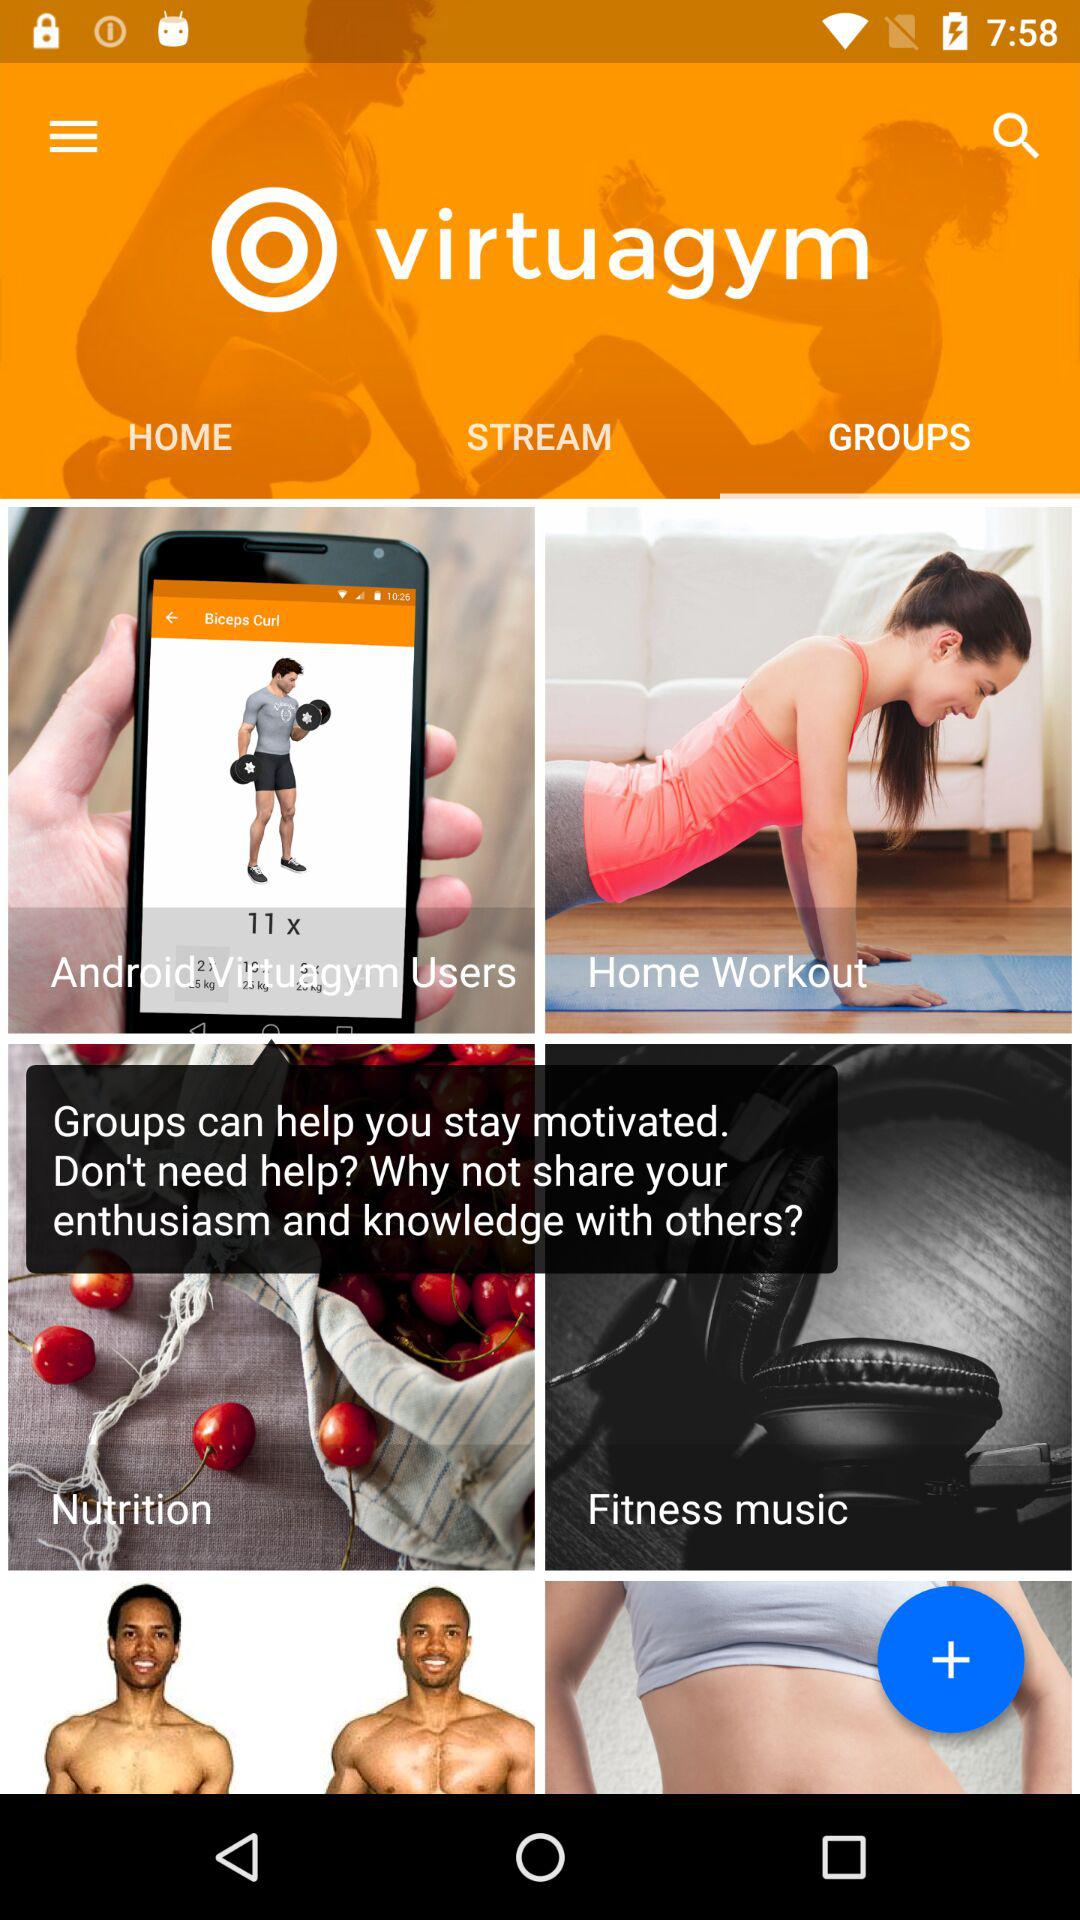What is the application name? The application name is "virtuagym". 